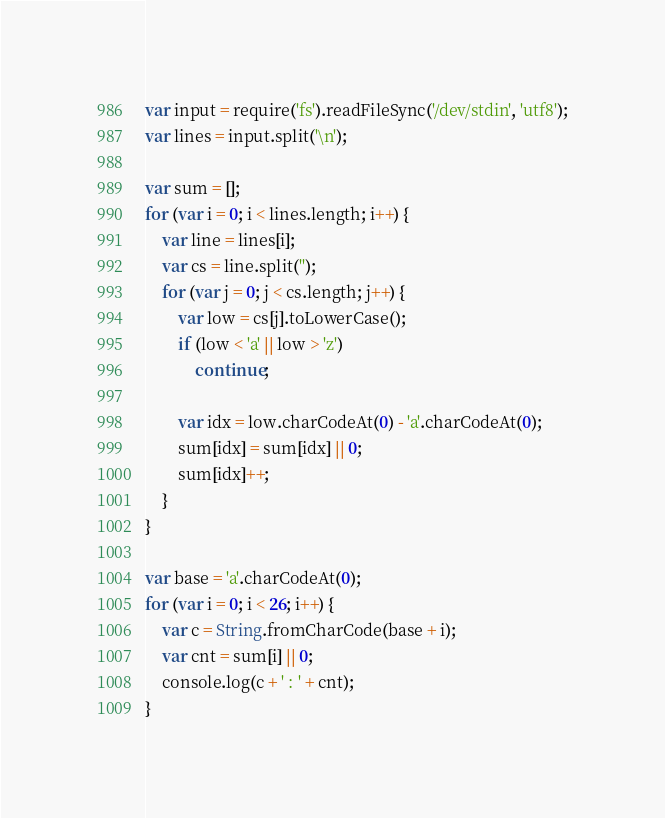<code> <loc_0><loc_0><loc_500><loc_500><_JavaScript_>var input = require('fs').readFileSync('/dev/stdin', 'utf8');
var lines = input.split('\n');

var sum = [];
for (var i = 0; i < lines.length; i++) {
	var line = lines[i];
	var cs = line.split('');
	for (var j = 0; j < cs.length; j++) {
		var low = cs[j].toLowerCase();
		if (low < 'a' || low > 'z')
			continue;

		var idx = low.charCodeAt(0) - 'a'.charCodeAt(0);
		sum[idx] = sum[idx] || 0;
		sum[idx]++;
	}
}

var base = 'a'.charCodeAt(0);
for (var i = 0; i < 26; i++) {
	var c = String.fromCharCode(base + i);
	var cnt = sum[i] || 0;
	console.log(c + ' : ' + cnt);
}</code> 